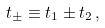<formula> <loc_0><loc_0><loc_500><loc_500>t _ { \pm } \equiv t _ { 1 } \pm t _ { 2 } \, ,</formula> 